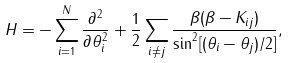Convert formula to latex. <formula><loc_0><loc_0><loc_500><loc_500>H = - \sum _ { i = 1 } ^ { N } \frac { \partial ^ { 2 } } { \partial \theta _ { i } ^ { 2 } } + \frac { 1 } { 2 } \sum _ { i \ne j } \frac { \beta ( \beta - K _ { i j } ) } { \sin ^ { 2 } [ ( \theta _ { i } - \theta _ { j } ) / 2 ] } ,</formula> 